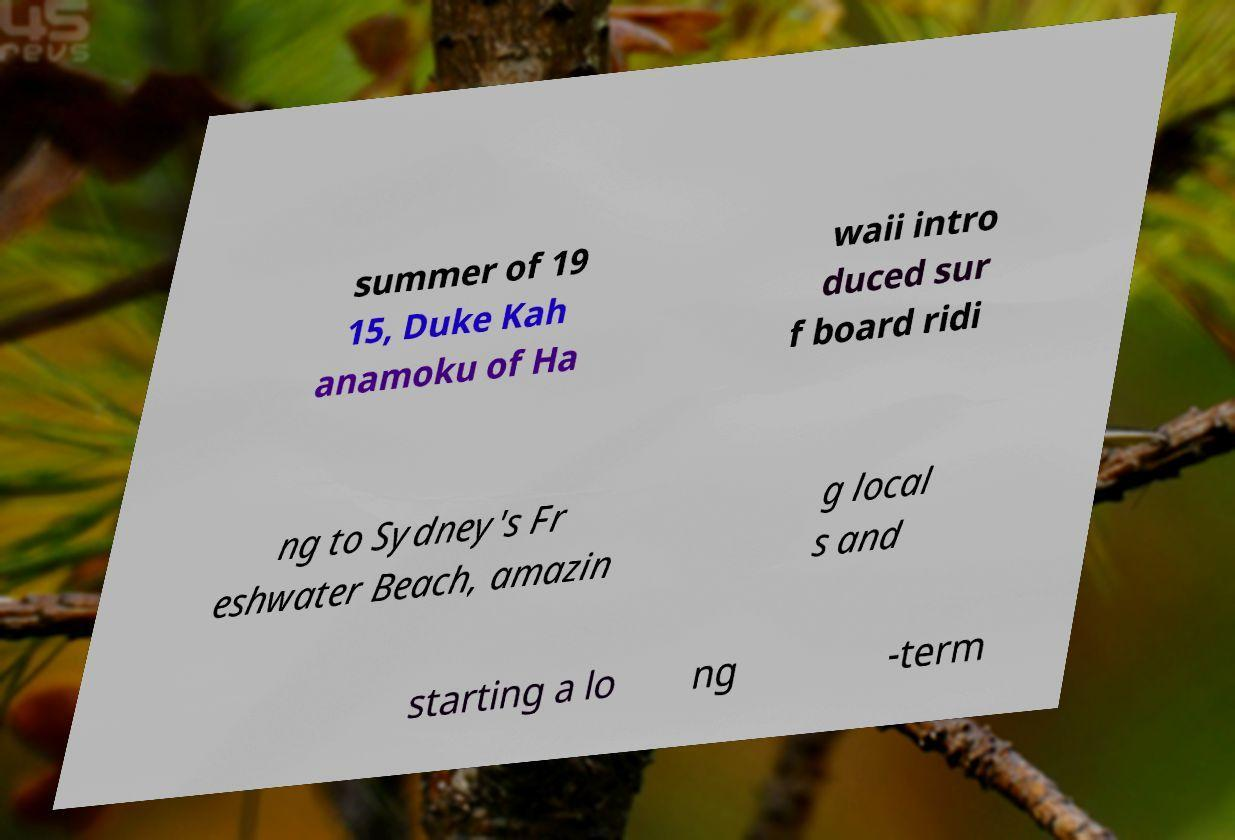Please read and relay the text visible in this image. What does it say? summer of 19 15, Duke Kah anamoku of Ha waii intro duced sur f board ridi ng to Sydney's Fr eshwater Beach, amazin g local s and starting a lo ng -term 